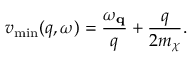Convert formula to latex. <formula><loc_0><loc_0><loc_500><loc_500>v _ { \min } ( q , \omega ) = \frac { \omega _ { q } } { q } + \frac { q } { 2 m _ { \chi } } .</formula> 